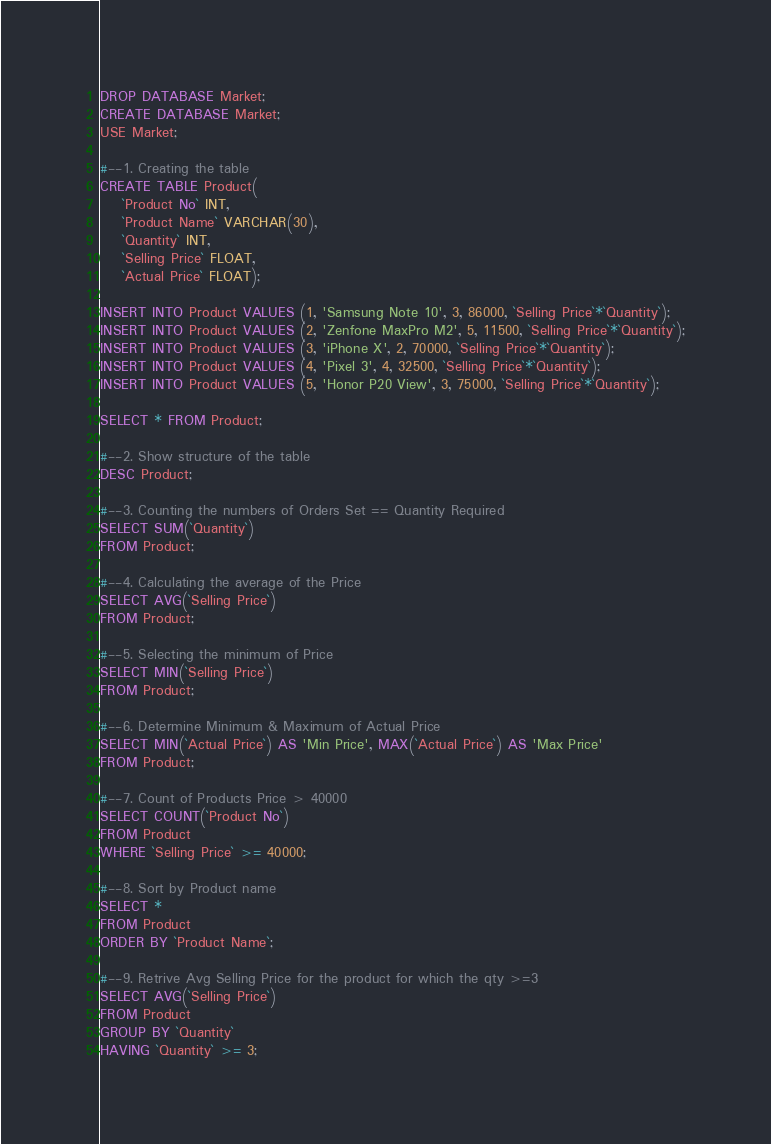Convert code to text. <code><loc_0><loc_0><loc_500><loc_500><_SQL_>DROP DATABASE Market;
CREATE DATABASE Market;
USE Market;

#--1. Creating the table
CREATE TABLE Product(
	`Product No` INT,
	`Product Name` VARCHAR(30),
	`Quantity` INT,
	`Selling Price` FLOAT,
	`Actual Price` FLOAT);

INSERT INTO Product VALUES (1, 'Samsung Note 10', 3, 86000, `Selling Price`*`Quantity`);
INSERT INTO Product VALUES (2, 'Zenfone MaxPro M2', 5, 11500, `Selling Price`*`Quantity`);
INSERT INTO Product VALUES (3, 'iPhone X', 2, 70000, `Selling Price`*`Quantity`);
INSERT INTO Product VALUES (4, 'Pixel 3', 4, 32500, `Selling Price`*`Quantity`);
INSERT INTO Product VALUES (5, 'Honor P20 View', 3, 75000, `Selling Price`*`Quantity`);

SELECT * FROM Product;

#--2. Show structure of the table
DESC Product;

#--3. Counting the numbers of Orders Set == Quantity Required
SELECT SUM(`Quantity`)
FROM Product;

#--4. Calculating the average of the Price
SELECT AVG(`Selling Price`)
FROM Product;

#--5. Selecting the minimum of Price
SELECT MIN(`Selling Price`)
FROM Product;

#--6. Determine Minimum & Maximum of Actual Price
SELECT MIN(`Actual Price`) AS 'Min Price', MAX(`Actual Price`) AS 'Max Price'
FROM Product;

#--7. Count of Products Price > 40000
SELECT COUNT(`Product No`)
FROM Product
WHERE `Selling Price` >= 40000;

#--8. Sort by Product name
SELECT *
FROM Product
ORDER BY `Product Name`;

#--9. Retrive Avg Selling Price for the product for which the qty >=3
SELECT AVG(`Selling Price`)
FROM Product
GROUP BY `Quantity`
HAVING `Quantity` >= 3;
</code> 